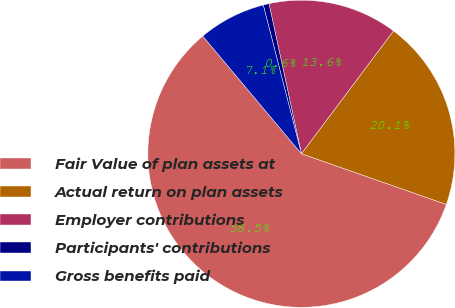<chart> <loc_0><loc_0><loc_500><loc_500><pie_chart><fcel>Fair Value of plan assets at<fcel>Actual return on plan assets<fcel>Employer contributions<fcel>Participants' contributions<fcel>Gross benefits paid<nl><fcel>58.55%<fcel>20.12%<fcel>13.62%<fcel>0.61%<fcel>7.11%<nl></chart> 